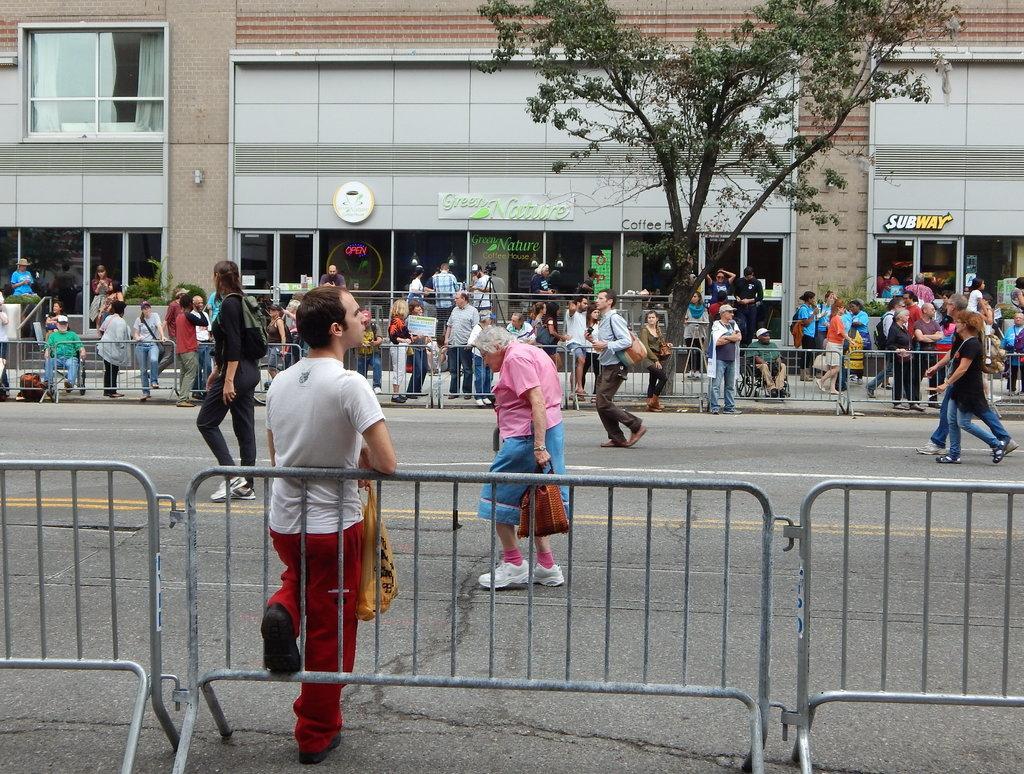Please provide a concise description of this image. In this image I can see the road, few persons walking on the road, the railing, a person standing and in the background I can see number of persons are standing on the sidewalk, few trees, few boards and a building. 